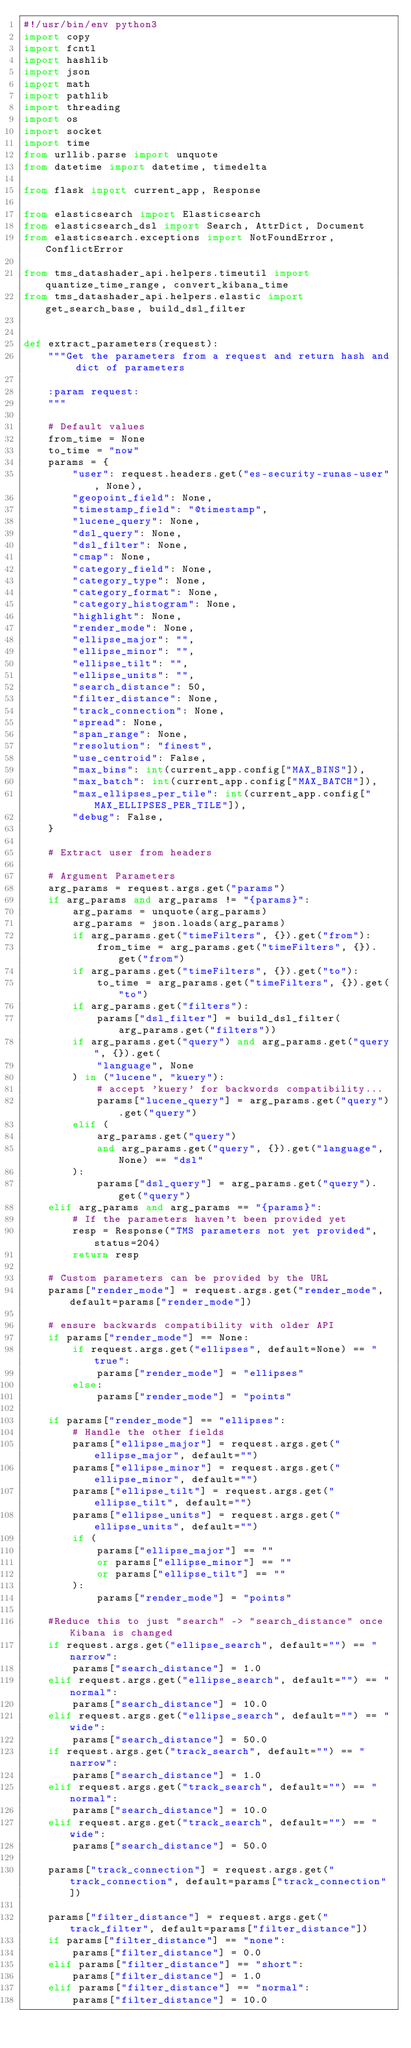Convert code to text. <code><loc_0><loc_0><loc_500><loc_500><_Python_>#!/usr/bin/env python3
import copy
import fcntl
import hashlib
import json
import math
import pathlib
import threading
import os
import socket
import time
from urllib.parse import unquote
from datetime import datetime, timedelta

from flask import current_app, Response

from elasticsearch import Elasticsearch
from elasticsearch_dsl import Search, AttrDict, Document
from elasticsearch.exceptions import NotFoundError, ConflictError

from tms_datashader_api.helpers.timeutil import quantize_time_range, convert_kibana_time
from tms_datashader_api.helpers.elastic import get_search_base, build_dsl_filter


def extract_parameters(request):
    """Get the parameters from a request and return hash and dict of parameters

    :param request:
    """

    # Default values
    from_time = None
    to_time = "now"
    params = {
        "user": request.headers.get("es-security-runas-user", None),
        "geopoint_field": None,
        "timestamp_field": "@timestamp",
        "lucene_query": None,
        "dsl_query": None,
        "dsl_filter": None,
        "cmap": None,
        "category_field": None,
        "category_type": None,
        "category_format": None,
        "category_histogram": None,
        "highlight": None,
        "render_mode": None,
        "ellipse_major": "",
        "ellipse_minor": "",
        "ellipse_tilt": "",
        "ellipse_units": "",
        "search_distance": 50,
        "filter_distance": None,
        "track_connection": None,
        "spread": None,
        "span_range": None,
        "resolution": "finest",
        "use_centroid": False,
        "max_bins": int(current_app.config["MAX_BINS"]),
        "max_batch": int(current_app.config["MAX_BATCH"]),
        "max_ellipses_per_tile": int(current_app.config["MAX_ELLIPSES_PER_TILE"]),
        "debug": False,
    }

    # Extract user from headers

    # Argument Parameters
    arg_params = request.args.get("params")
    if arg_params and arg_params != "{params}":
        arg_params = unquote(arg_params)
        arg_params = json.loads(arg_params)
        if arg_params.get("timeFilters", {}).get("from"):
            from_time = arg_params.get("timeFilters", {}).get("from")
        if arg_params.get("timeFilters", {}).get("to"):
            to_time = arg_params.get("timeFilters", {}).get("to")
        if arg_params.get("filters"):
            params["dsl_filter"] = build_dsl_filter(arg_params.get("filters"))
        if arg_params.get("query") and arg_params.get("query", {}).get(
            "language", None
        ) in ("lucene", "kuery"):
            # accept 'kuery' for backwords compatibility...
            params["lucene_query"] = arg_params.get("query").get("query")
        elif (
            arg_params.get("query")
            and arg_params.get("query", {}).get("language", None) == "dsl"
        ):
            params["dsl_query"] = arg_params.get("query").get("query")
    elif arg_params and arg_params == "{params}":
        # If the parameters haven't been provided yet
        resp = Response("TMS parameters not yet provided", status=204)
        return resp

    # Custom parameters can be provided by the URL
    params["render_mode"] = request.args.get("render_mode", default=params["render_mode"])
    
    # ensure backwards compatibility with older API
    if params["render_mode"] == None:
        if request.args.get("ellipses", default=None) == "true":
            params["render_mode"] = "ellipses"
        else:
            params["render_mode"] = "points"

    if params["render_mode"] == "ellipses":
        # Handle the other fields
        params["ellipse_major"] = request.args.get("ellipse_major", default="")
        params["ellipse_minor"] = request.args.get("ellipse_minor", default="")
        params["ellipse_tilt"] = request.args.get("ellipse_tilt", default="")
        params["ellipse_units"] = request.args.get("ellipse_units", default="")
        if (
            params["ellipse_major"] == ""
            or params["ellipse_minor"] == ""
            or params["ellipse_tilt"] == ""
        ):
            params["render_mode"] = "points"
    
    #Reduce this to just "search" -> "search_distance" once Kibana is changed
    if request.args.get("ellipse_search", default="") == "narrow":
        params["search_distance"] = 1.0
    elif request.args.get("ellipse_search", default="") == "normal":
        params["search_distance"] = 10.0
    elif request.args.get("ellipse_search", default="") == "wide":
        params["search_distance"] = 50.0
    if request.args.get("track_search", default="") == "narrow":
        params["search_distance"] = 1.0
    elif request.args.get("track_search", default="") == "normal":
        params["search_distance"] = 10.0
    elif request.args.get("track_search", default="") == "wide":
        params["search_distance"] = 50.0

    params["track_connection"] = request.args.get("track_connection", default=params["track_connection"])
    
    params["filter_distance"] = request.args.get("track_filter", default=params["filter_distance"])
    if params["filter_distance"] == "none":
        params["filter_distance"] = 0.0
    elif params["filter_distance"] == "short":
        params["filter_distance"] = 1.0
    elif params["filter_distance"] == "normal":
        params["filter_distance"] = 10.0</code> 